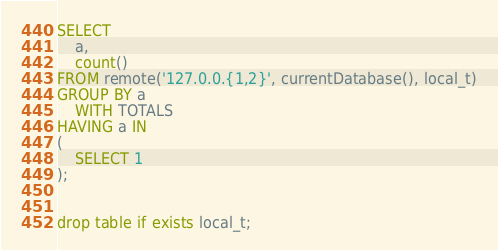<code> <loc_0><loc_0><loc_500><loc_500><_SQL_>SELECT
    a,
    count()
FROM remote('127.0.0.{1,2}', currentDatabase(), local_t)
GROUP BY a
    WITH TOTALS
HAVING a IN 
(
    SELECT 1
);


drop table if exists local_t;</code> 